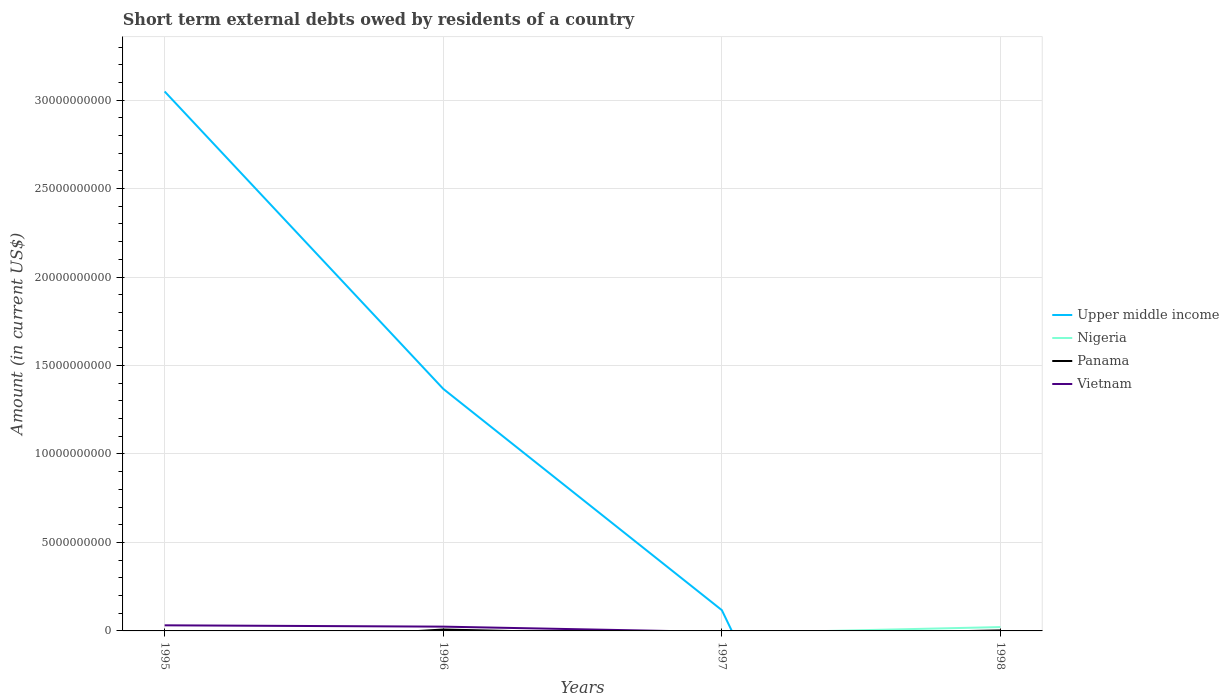How many different coloured lines are there?
Keep it short and to the point. 4. Does the line corresponding to Upper middle income intersect with the line corresponding to Panama?
Provide a short and direct response. Yes. Is the number of lines equal to the number of legend labels?
Keep it short and to the point. No. Across all years, what is the maximum amount of short-term external debts owed by residents in Nigeria?
Make the answer very short. 0. What is the total amount of short-term external debts owed by residents in Upper middle income in the graph?
Offer a very short reply. 2.93e+1. What is the difference between the highest and the second highest amount of short-term external debts owed by residents in Upper middle income?
Ensure brevity in your answer.  3.05e+1. How many lines are there?
Your answer should be compact. 4. How many years are there in the graph?
Make the answer very short. 4. Are the values on the major ticks of Y-axis written in scientific E-notation?
Give a very brief answer. No. How are the legend labels stacked?
Provide a succinct answer. Vertical. What is the title of the graph?
Keep it short and to the point. Short term external debts owed by residents of a country. What is the Amount (in current US$) of Upper middle income in 1995?
Provide a succinct answer. 3.05e+1. What is the Amount (in current US$) of Nigeria in 1995?
Your answer should be compact. 0. What is the Amount (in current US$) in Panama in 1995?
Offer a terse response. 0. What is the Amount (in current US$) of Vietnam in 1995?
Give a very brief answer. 3.17e+08. What is the Amount (in current US$) in Upper middle income in 1996?
Keep it short and to the point. 1.37e+1. What is the Amount (in current US$) in Panama in 1996?
Your answer should be very brief. 8.00e+07. What is the Amount (in current US$) in Vietnam in 1996?
Give a very brief answer. 2.42e+08. What is the Amount (in current US$) of Upper middle income in 1997?
Give a very brief answer. 1.17e+09. What is the Amount (in current US$) in Nigeria in 1997?
Give a very brief answer. 0. What is the Amount (in current US$) of Vietnam in 1997?
Provide a short and direct response. 0. What is the Amount (in current US$) in Upper middle income in 1998?
Provide a short and direct response. 0. What is the Amount (in current US$) in Nigeria in 1998?
Your response must be concise. 2.18e+08. What is the Amount (in current US$) of Panama in 1998?
Provide a succinct answer. 2.90e+07. Across all years, what is the maximum Amount (in current US$) in Upper middle income?
Offer a very short reply. 3.05e+1. Across all years, what is the maximum Amount (in current US$) in Nigeria?
Your answer should be compact. 2.18e+08. Across all years, what is the maximum Amount (in current US$) in Panama?
Give a very brief answer. 8.00e+07. Across all years, what is the maximum Amount (in current US$) of Vietnam?
Your answer should be compact. 3.17e+08. Across all years, what is the minimum Amount (in current US$) in Upper middle income?
Keep it short and to the point. 0. Across all years, what is the minimum Amount (in current US$) of Nigeria?
Offer a terse response. 0. Across all years, what is the minimum Amount (in current US$) in Vietnam?
Keep it short and to the point. 0. What is the total Amount (in current US$) in Upper middle income in the graph?
Give a very brief answer. 4.53e+1. What is the total Amount (in current US$) of Nigeria in the graph?
Ensure brevity in your answer.  2.18e+08. What is the total Amount (in current US$) in Panama in the graph?
Ensure brevity in your answer.  1.09e+08. What is the total Amount (in current US$) in Vietnam in the graph?
Your answer should be compact. 5.59e+08. What is the difference between the Amount (in current US$) of Upper middle income in 1995 and that in 1996?
Your answer should be very brief. 1.68e+1. What is the difference between the Amount (in current US$) of Vietnam in 1995 and that in 1996?
Your response must be concise. 7.46e+07. What is the difference between the Amount (in current US$) of Upper middle income in 1995 and that in 1997?
Provide a short and direct response. 2.93e+1. What is the difference between the Amount (in current US$) in Upper middle income in 1996 and that in 1997?
Your answer should be very brief. 1.25e+1. What is the difference between the Amount (in current US$) of Panama in 1996 and that in 1998?
Your answer should be very brief. 5.10e+07. What is the difference between the Amount (in current US$) in Upper middle income in 1995 and the Amount (in current US$) in Panama in 1996?
Provide a short and direct response. 3.04e+1. What is the difference between the Amount (in current US$) of Upper middle income in 1995 and the Amount (in current US$) of Vietnam in 1996?
Offer a very short reply. 3.02e+1. What is the difference between the Amount (in current US$) of Upper middle income in 1995 and the Amount (in current US$) of Nigeria in 1998?
Ensure brevity in your answer.  3.03e+1. What is the difference between the Amount (in current US$) of Upper middle income in 1995 and the Amount (in current US$) of Panama in 1998?
Your answer should be very brief. 3.05e+1. What is the difference between the Amount (in current US$) in Upper middle income in 1996 and the Amount (in current US$) in Nigeria in 1998?
Offer a terse response. 1.35e+1. What is the difference between the Amount (in current US$) in Upper middle income in 1996 and the Amount (in current US$) in Panama in 1998?
Ensure brevity in your answer.  1.37e+1. What is the difference between the Amount (in current US$) in Upper middle income in 1997 and the Amount (in current US$) in Nigeria in 1998?
Your answer should be very brief. 9.54e+08. What is the difference between the Amount (in current US$) of Upper middle income in 1997 and the Amount (in current US$) of Panama in 1998?
Make the answer very short. 1.14e+09. What is the average Amount (in current US$) of Upper middle income per year?
Provide a short and direct response. 1.13e+1. What is the average Amount (in current US$) of Nigeria per year?
Give a very brief answer. 5.46e+07. What is the average Amount (in current US$) of Panama per year?
Offer a very short reply. 2.72e+07. What is the average Amount (in current US$) of Vietnam per year?
Keep it short and to the point. 1.40e+08. In the year 1995, what is the difference between the Amount (in current US$) of Upper middle income and Amount (in current US$) of Vietnam?
Offer a terse response. 3.02e+1. In the year 1996, what is the difference between the Amount (in current US$) of Upper middle income and Amount (in current US$) of Panama?
Your answer should be very brief. 1.36e+1. In the year 1996, what is the difference between the Amount (in current US$) of Upper middle income and Amount (in current US$) of Vietnam?
Offer a terse response. 1.34e+1. In the year 1996, what is the difference between the Amount (in current US$) in Panama and Amount (in current US$) in Vietnam?
Offer a very short reply. -1.62e+08. In the year 1998, what is the difference between the Amount (in current US$) of Nigeria and Amount (in current US$) of Panama?
Your answer should be very brief. 1.89e+08. What is the ratio of the Amount (in current US$) in Upper middle income in 1995 to that in 1996?
Your answer should be compact. 2.23. What is the ratio of the Amount (in current US$) in Vietnam in 1995 to that in 1996?
Your answer should be very brief. 1.31. What is the ratio of the Amount (in current US$) of Upper middle income in 1995 to that in 1997?
Your response must be concise. 26. What is the ratio of the Amount (in current US$) of Upper middle income in 1996 to that in 1997?
Provide a short and direct response. 11.67. What is the ratio of the Amount (in current US$) in Panama in 1996 to that in 1998?
Offer a very short reply. 2.76. What is the difference between the highest and the second highest Amount (in current US$) of Upper middle income?
Offer a terse response. 1.68e+1. What is the difference between the highest and the lowest Amount (in current US$) in Upper middle income?
Provide a short and direct response. 3.05e+1. What is the difference between the highest and the lowest Amount (in current US$) in Nigeria?
Make the answer very short. 2.18e+08. What is the difference between the highest and the lowest Amount (in current US$) of Panama?
Your response must be concise. 8.00e+07. What is the difference between the highest and the lowest Amount (in current US$) of Vietnam?
Give a very brief answer. 3.17e+08. 